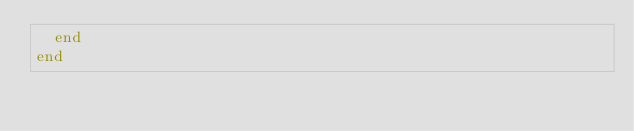Convert code to text. <code><loc_0><loc_0><loc_500><loc_500><_Ruby_>  end
end
</code> 